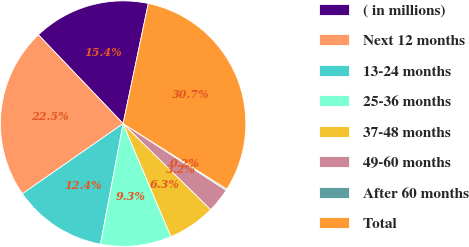<chart> <loc_0><loc_0><loc_500><loc_500><pie_chart><fcel>( in millions)<fcel>Next 12 months<fcel>13-24 months<fcel>25-36 months<fcel>37-48 months<fcel>49-60 months<fcel>After 60 months<fcel>Total<nl><fcel>15.42%<fcel>22.55%<fcel>12.37%<fcel>9.32%<fcel>6.27%<fcel>3.22%<fcel>0.17%<fcel>30.68%<nl></chart> 